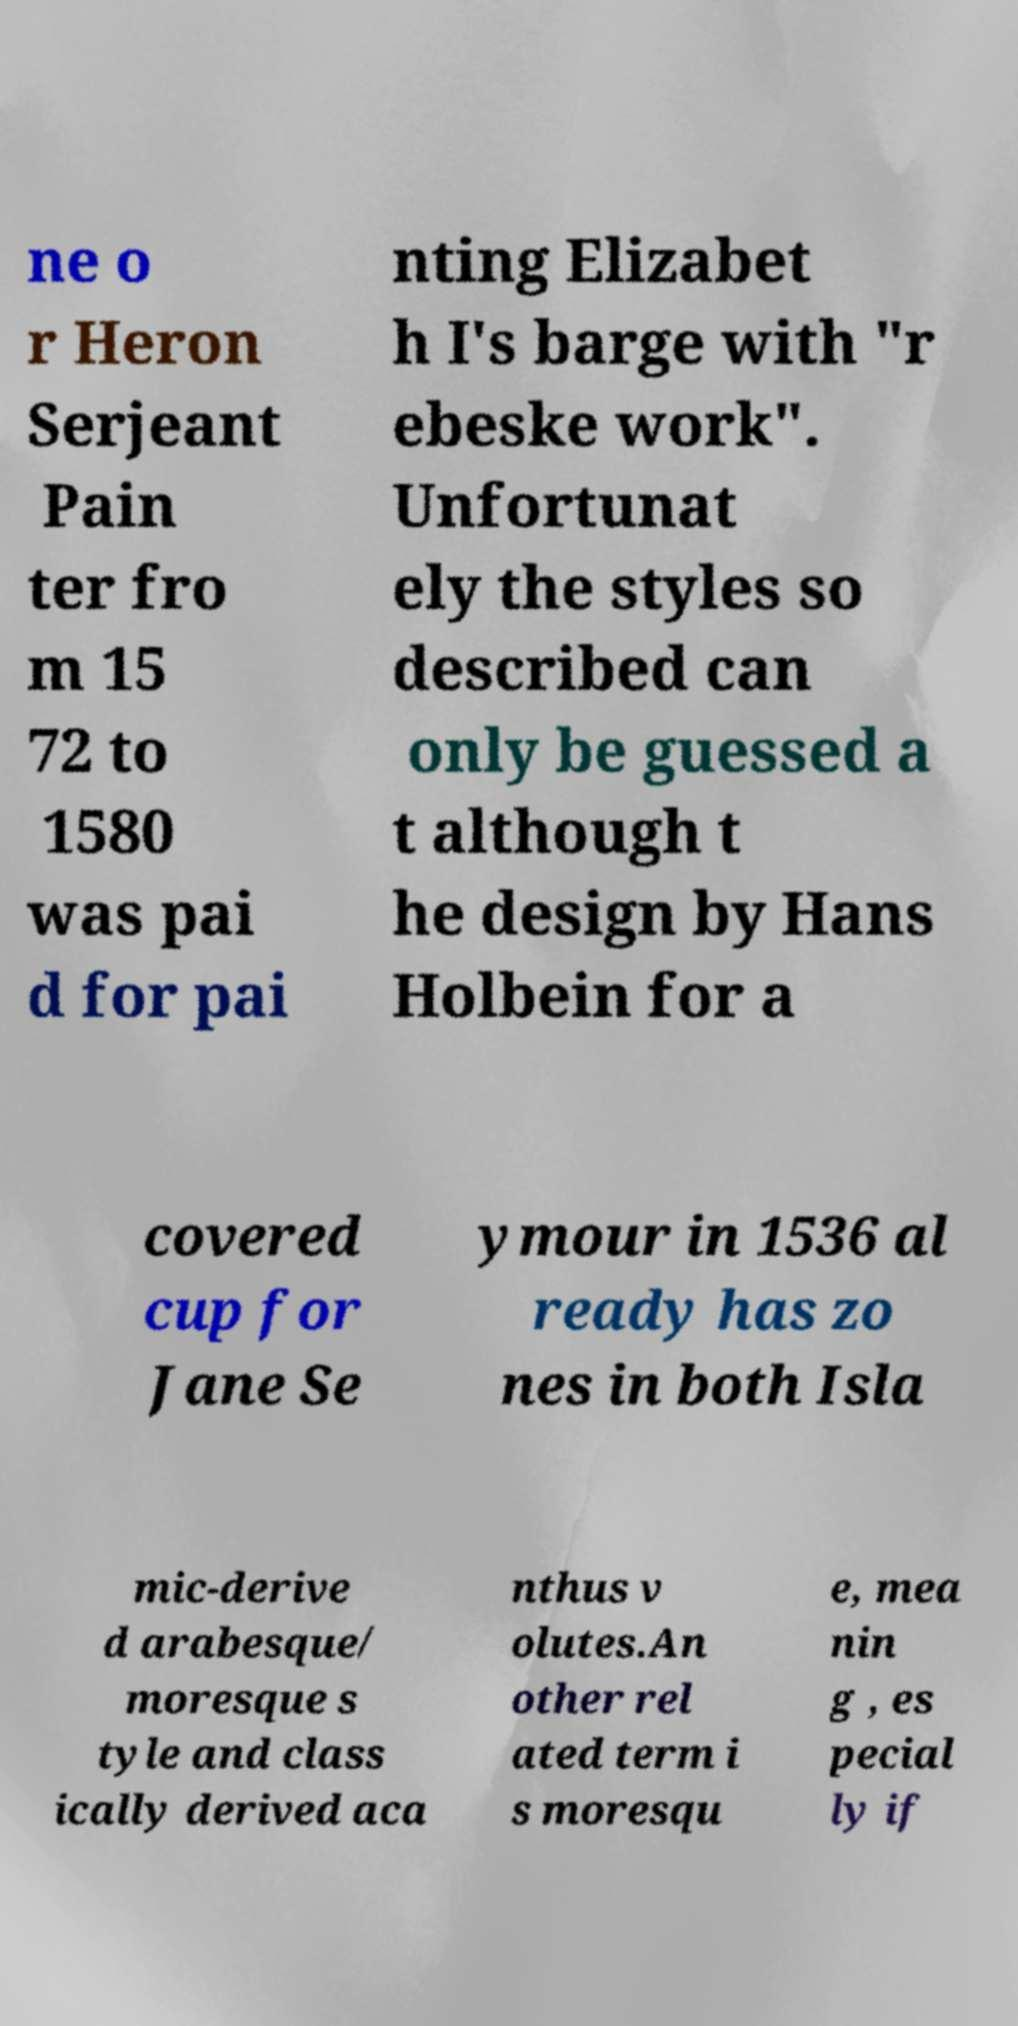Please read and relay the text visible in this image. What does it say? ne o r Heron Serjeant Pain ter fro m 15 72 to 1580 was pai d for pai nting Elizabet h I's barge with "r ebeske work". Unfortunat ely the styles so described can only be guessed a t although t he design by Hans Holbein for a covered cup for Jane Se ymour in 1536 al ready has zo nes in both Isla mic-derive d arabesque/ moresque s tyle and class ically derived aca nthus v olutes.An other rel ated term i s moresqu e, mea nin g , es pecial ly if 